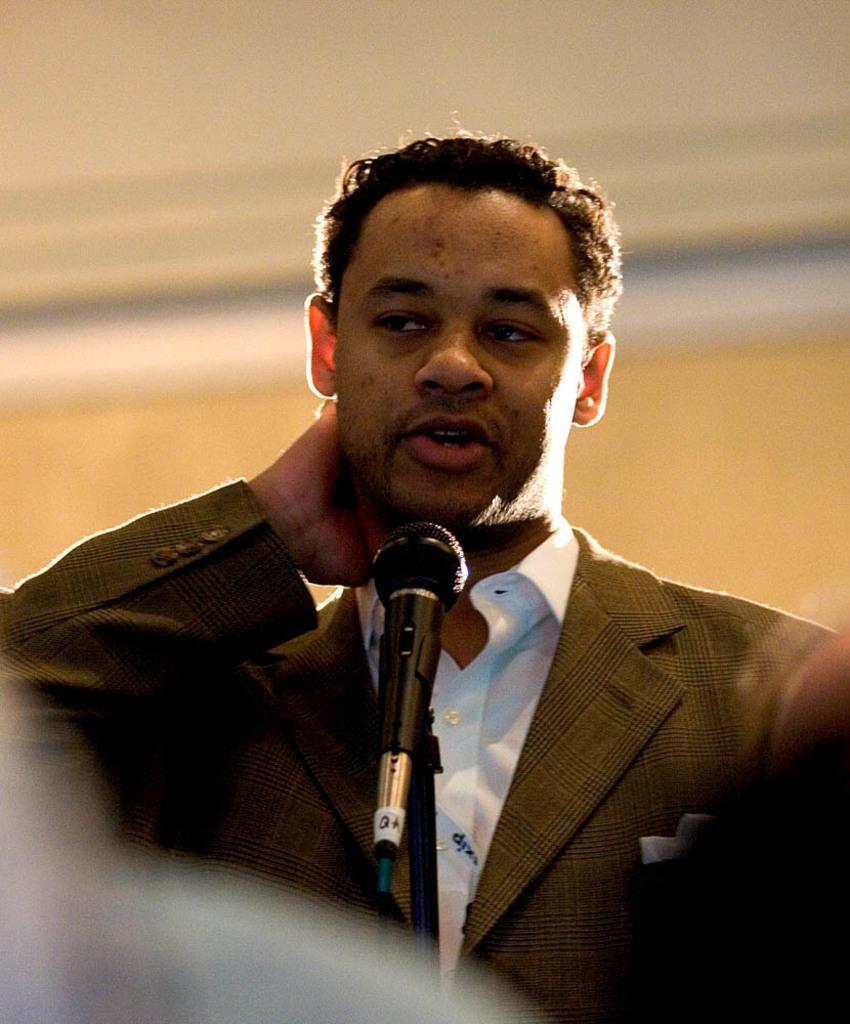How would you summarize this image in a sentence or two? In this image I can see a person in front of a mike and wall. This image is taken may be in a hall. 